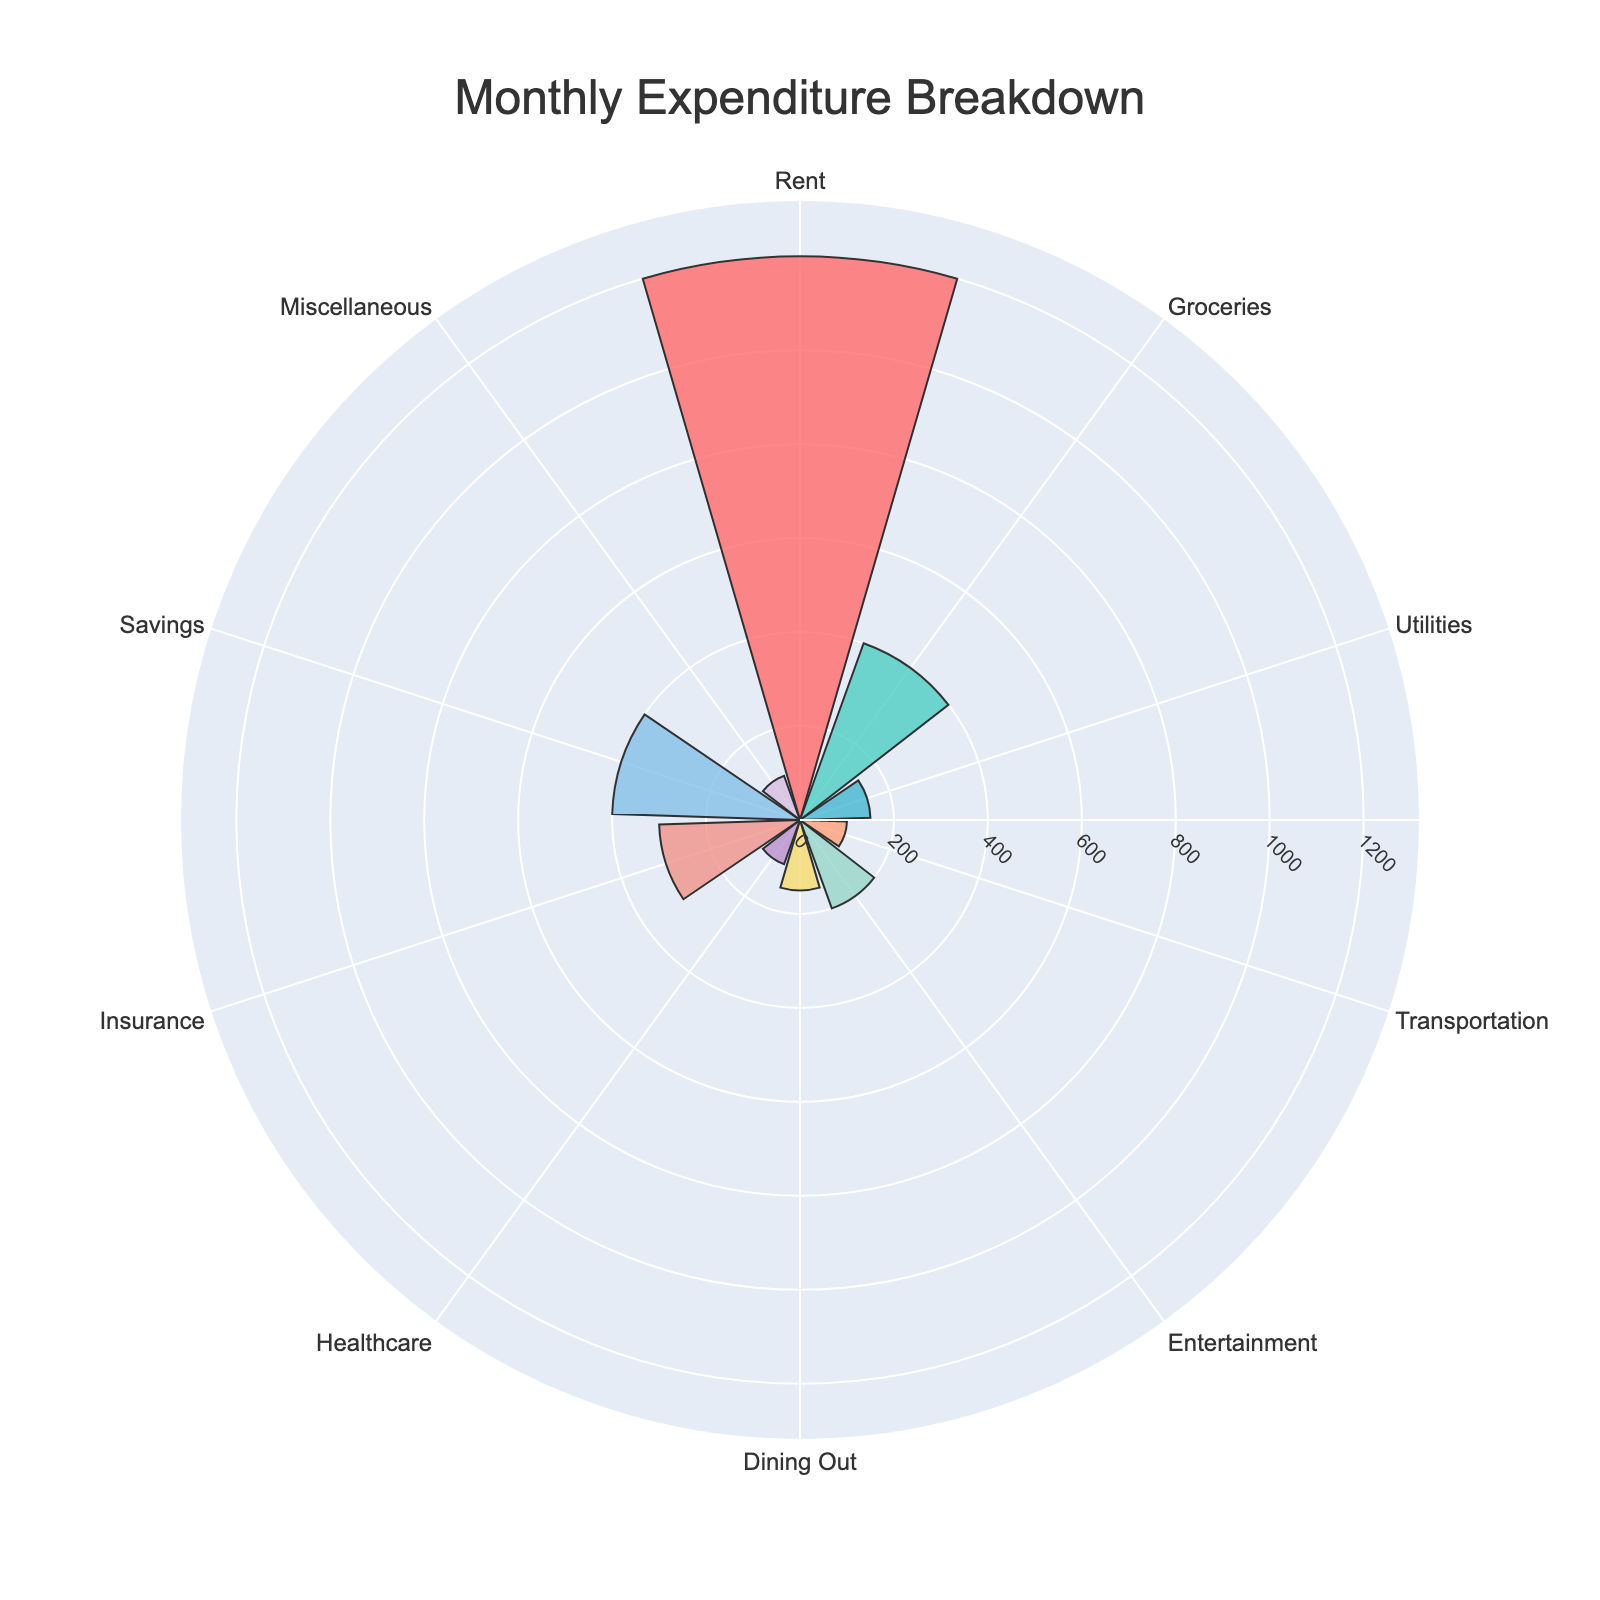What's the title of the chart? The title is usually displayed at the top of the chart. By looking at the figure, you can easily see the text "Monthly Expenditure Breakdown".
Answer: Monthly Expenditure Breakdown How many categories are included in the chart? By counting the different segments or labels around the chart, you can identify the total number of categories.
Answer: 10 Which category has the highest expenditure? The length of the segments (bars) in a polar area chart represents the amount. The longest segment corresponds to the highest expenditure.
Answer: Rent What is the total expenditure on Utilities and Healthcare combined? Locate the segments for Utilities and Healthcare and sum their values (150 for Utilities and 100 for Healthcare). 150 + 100 = 250
Answer: 250 Which categories have equal expenditures, and what are their amounts? Identify the segments with equal lengths, which represent equal values. Dining Out, Healthcare, and Transportation each have expenditure of 100.
Answer: Dining Out, Healthcare, Transportation (each 100) By how much does the expenditure on Rent exceed the expenditure on Groceries? Compare the lengths of the Rent and Groceries segments. Subtract the Groceries expenditure from the Rent expenditure (1200 - 400).
Answer: 800 What's the average expenditure per category? To find the average, sum all the expenditures and divide by the number of categories (1200 + 400 + 150 + 100 + 200 + 150 + 100 + 300 + 400 + 100) / 10 = 3100 / 10.
Answer: 310 How does the expenditure on Entertainment compare to the expenditure on Dining Out? Compare the lengths of the Entertainment and Dining Out segments. Entertainment has a longer segment than Dining Out, indicating a higher expenditure.
Answer: Entertainment is higher Which category has the smallest expenditure? Identify the shortest segment on the chart, which represents the smallest expenditure. Several categories have the shortest segment including Transportation, Healthcare, and Miscellaneous, all with expenditures of 100.
Answer: Transportation, Healthcare, Miscellaneous Is the expenditure on Insurance higher or lower than the total of Utilities and Dining Out? Compare the segment length of Insurance with the combined lengths of Utilities and Dining Out. Sum the Utilities and Dining Out expenditure (150 + 150) and compare it to Insurance (300). 300 is equal to 300.
Answer: Equal 